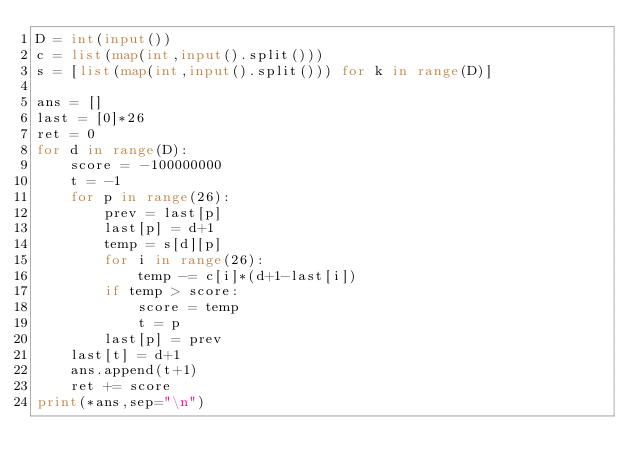<code> <loc_0><loc_0><loc_500><loc_500><_Python_>D = int(input())
c = list(map(int,input().split()))
s = [list(map(int,input().split())) for k in range(D)]

ans = []
last = [0]*26
ret = 0
for d in range(D):
    score = -100000000
    t = -1
    for p in range(26):
        prev = last[p]
        last[p] = d+1
        temp = s[d][p]
        for i in range(26):
            temp -= c[i]*(d+1-last[i])
        if temp > score:
            score = temp
            t = p
        last[p] = prev
    last[t] = d+1
    ans.append(t+1)
    ret += score
print(*ans,sep="\n")

</code> 